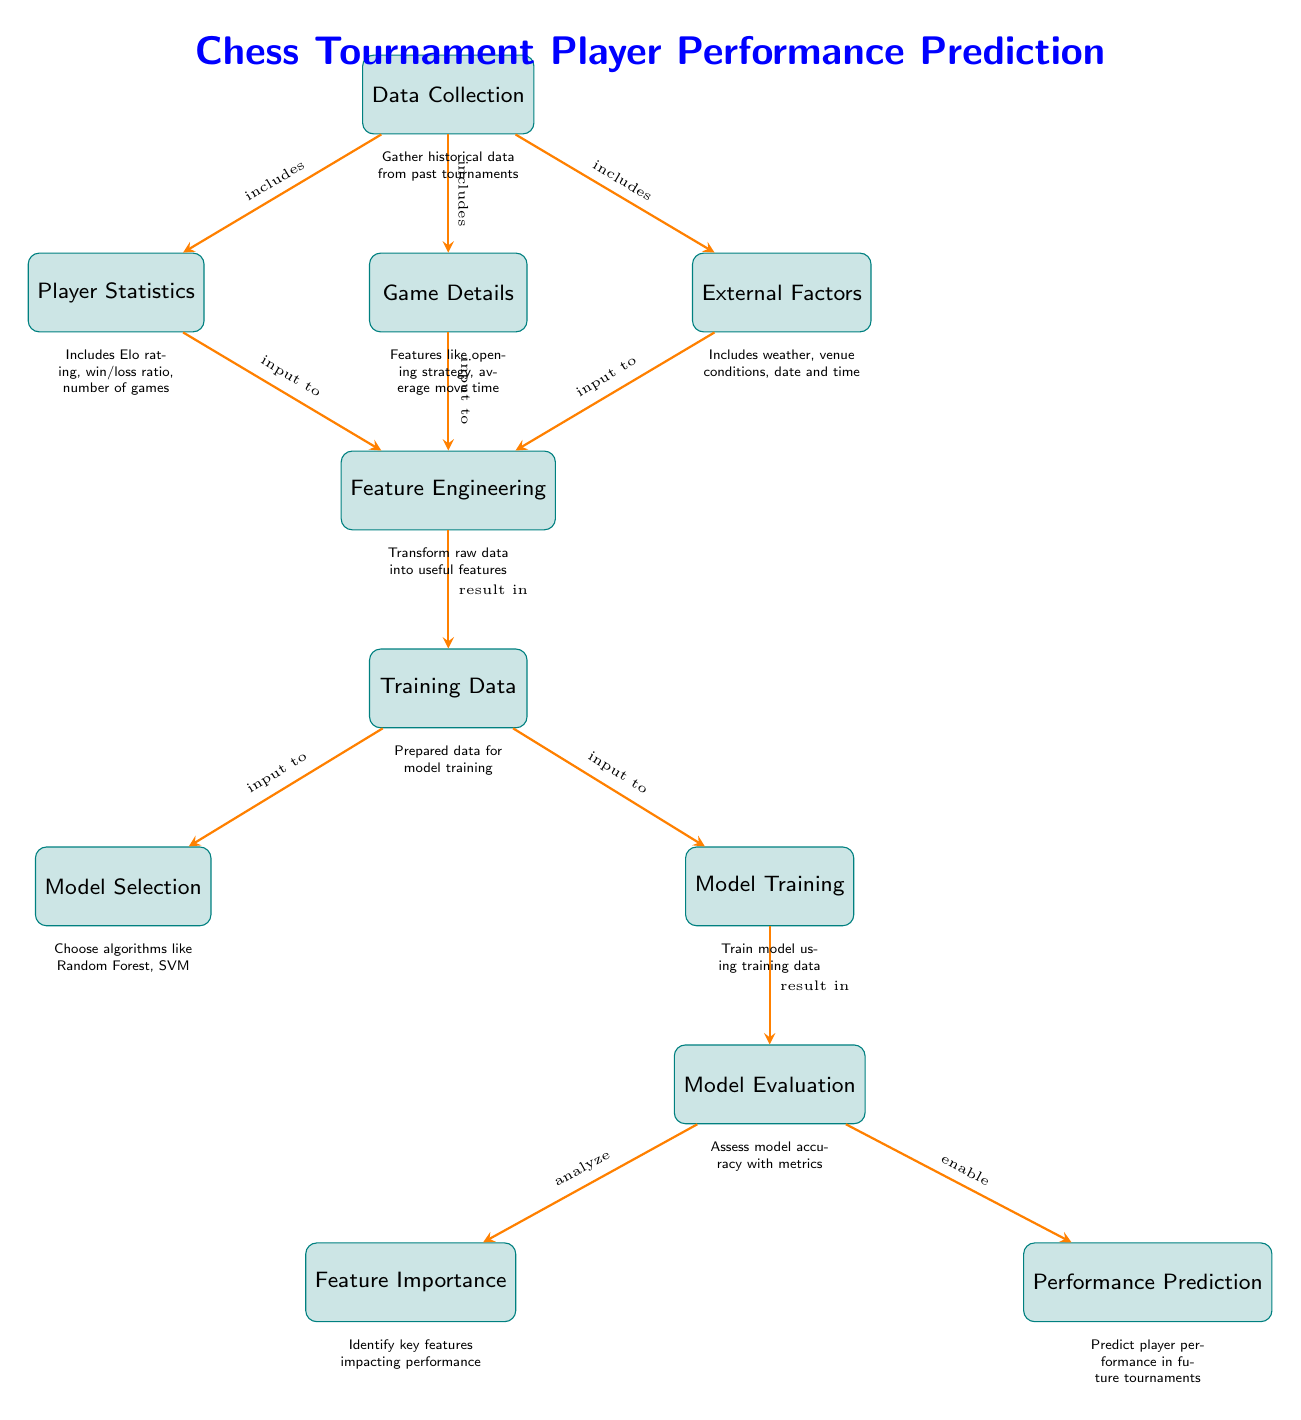What's the starting point in the diagram? The starting point in the diagram is the "Data Collection" node, which gathers historical data from past tournaments.
Answer: Data Collection How many main processes are shown in the diagram? The diagram has ten main processes represented by the boxes, from "Data Collection" to "Performance Prediction."
Answer: Ten Which factors are included in the "External Factors" node? The "External Factors" node includes weather, venue conditions, and date and time.
Answer: Weather, venue conditions, date and time What is the output of the "Model Evaluation"? The output of the "Model Evaluation" includes both "Feature Importance" and "Performance Prediction."
Answer: Feature Importance, Performance Prediction How does the "Game Details" contribute to the overall process? "Game Details" feeds into "Feature Engineering" as one of the inputs, contributing to feature transformation for model training.
Answer: Input to Feature Engineering Which node is responsible for identifying key features impacting performance? The "Feature Importance" node is responsible for identifying the key features impacting player performance in chess tournaments.
Answer: Feature Importance What is the purpose of "Feature Engineering" in this diagram? The purpose of "Feature Engineering" is to transform raw data into useful features that will be used for training models.
Answer: Transform raw data into useful features Which modeling techniques are suggested in the "Model Selection" node? The "Model Selection" node suggests algorithms like Random Forest and SVM for training the model.
Answer: Random Forest, SVM What phase comes directly after "Training Data"? The phase that comes directly after "Training Data" is "Model Selection."
Answer: Model Selection What is analyzed during the "Model Evaluation"? During "Model Evaluation," the accuracy of the model is assessed using various metrics.
Answer: Assess model accuracy with metrics 